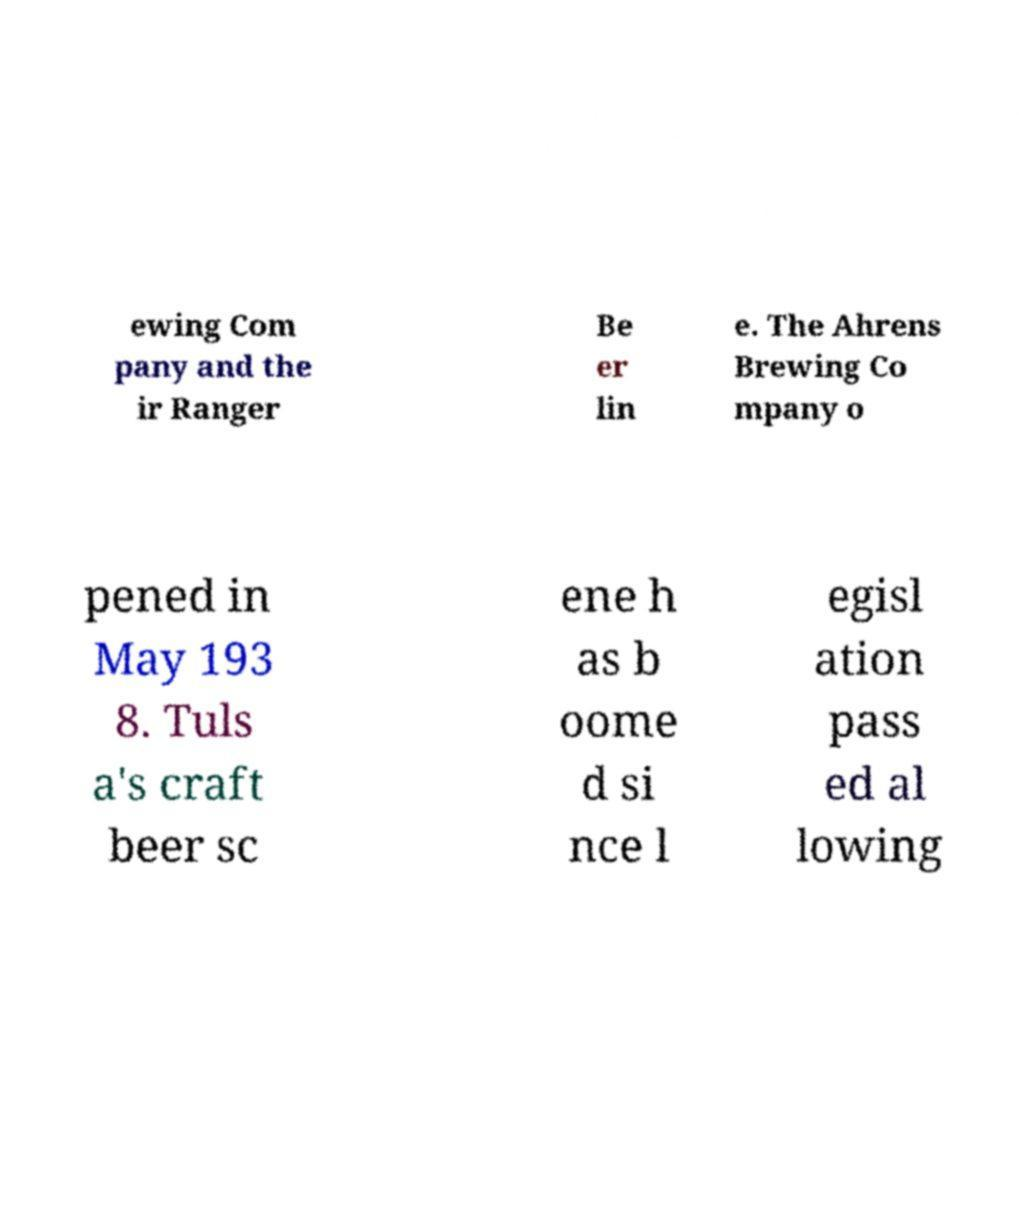Could you extract and type out the text from this image? ewing Com pany and the ir Ranger Be er lin e. The Ahrens Brewing Co mpany o pened in May 193 8. Tuls a's craft beer sc ene h as b oome d si nce l egisl ation pass ed al lowing 